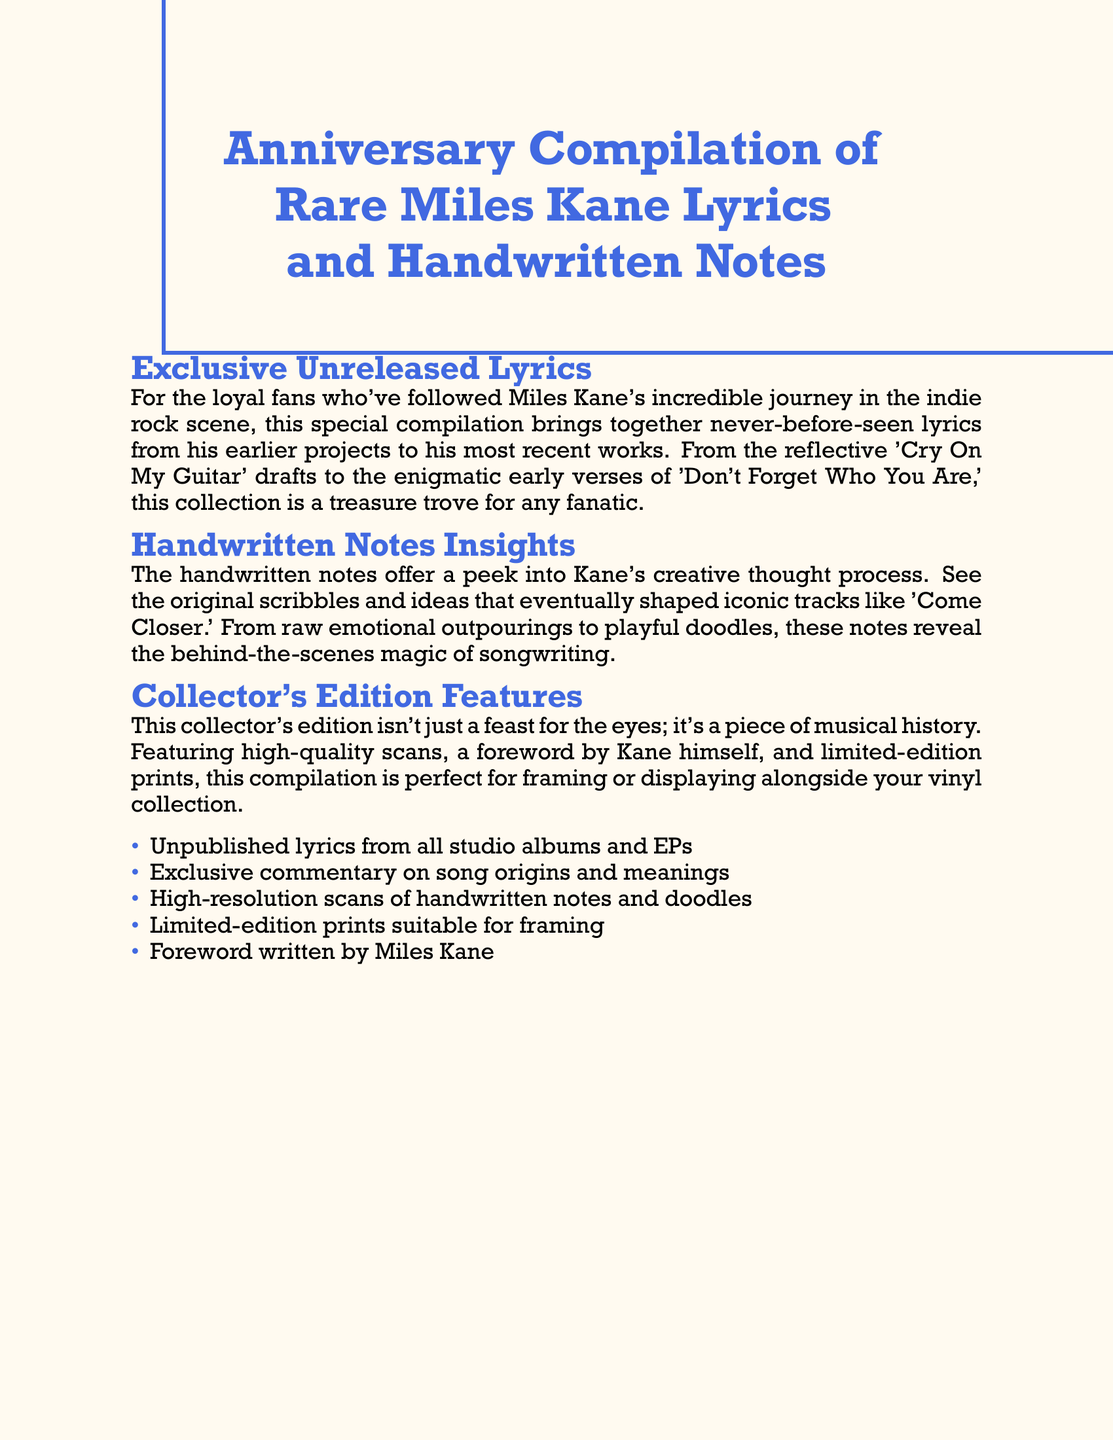What is the title of the compilation? The title of the compilation is found at the top of the document, presenting the subject matter clearly.
Answer: Anniversary Compilation of Rare Miles Kane Lyrics and Handwritten Notes What songs are mentioned in the compilation? The document lists specific songs that confirm the type of lyrics included in this compilation.
Answer: Cry On My Guitar, Don't Forget Who You Are, Come Closer Who wrote the foreword for the edition? The foreword is specifically mentioned to be written by a notable figure relevant to the content.
Answer: Miles Kane What type of content does the compilation feature? The types of content gathered in the compilation are explicitly stated in a heading within the document.
Answer: Exclusive Unreleased Lyrics What is a key feature of the collector's edition? The document highlights an important aspect of the collector's edition that makes it appealing to fans.
Answer: Limited-edition prints How many items are listed under the collector's edition features? The total items mentioned reflect the richness of the compilation's offerings.
Answer: Five What color is used for the text in the document? The text color is specifically described at the beginning of the document, emphasizing a certain aesthetic.
Answer: Indieblue What does the handwritten notes section provide? The purpose of the handwritten notes is summarized in the section title for clarity.
Answer: Insights into Kane's creative thought process 